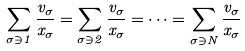<formula> <loc_0><loc_0><loc_500><loc_500>\sum _ { \sigma \ni 1 } \frac { v _ { \sigma } } { x _ { \sigma } } = \sum _ { \sigma \ni 2 } \frac { v _ { \sigma } } { x _ { \sigma } } = \dots = \sum _ { \sigma \ni N } \frac { v _ { \sigma } } { x _ { \sigma } }</formula> 